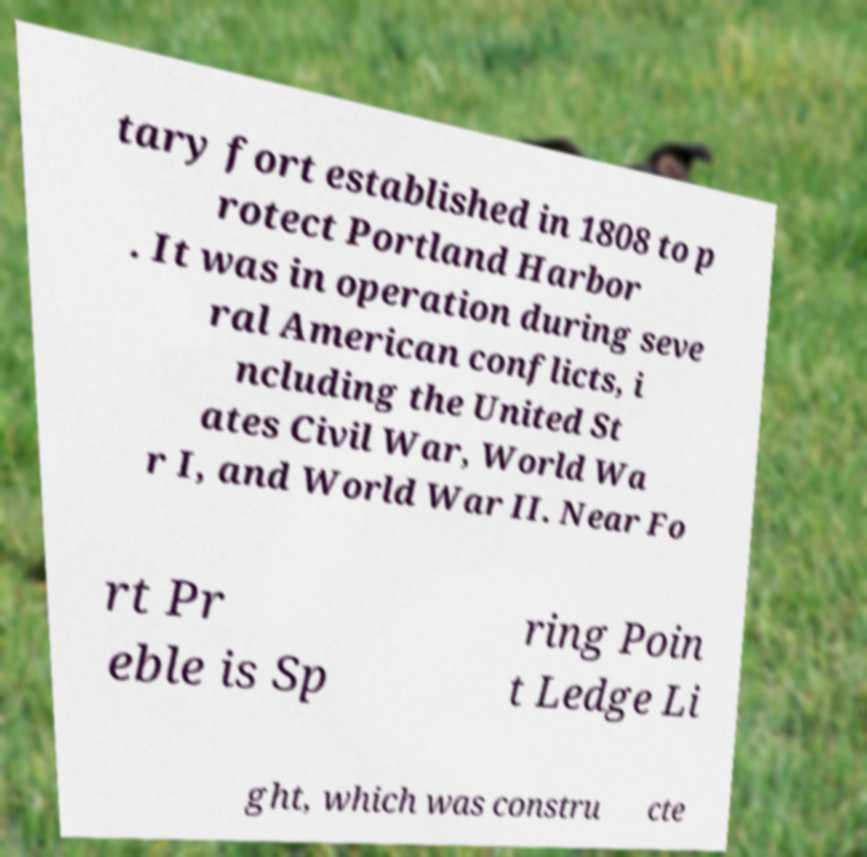I need the written content from this picture converted into text. Can you do that? tary fort established in 1808 to p rotect Portland Harbor . It was in operation during seve ral American conflicts, i ncluding the United St ates Civil War, World Wa r I, and World War II. Near Fo rt Pr eble is Sp ring Poin t Ledge Li ght, which was constru cte 